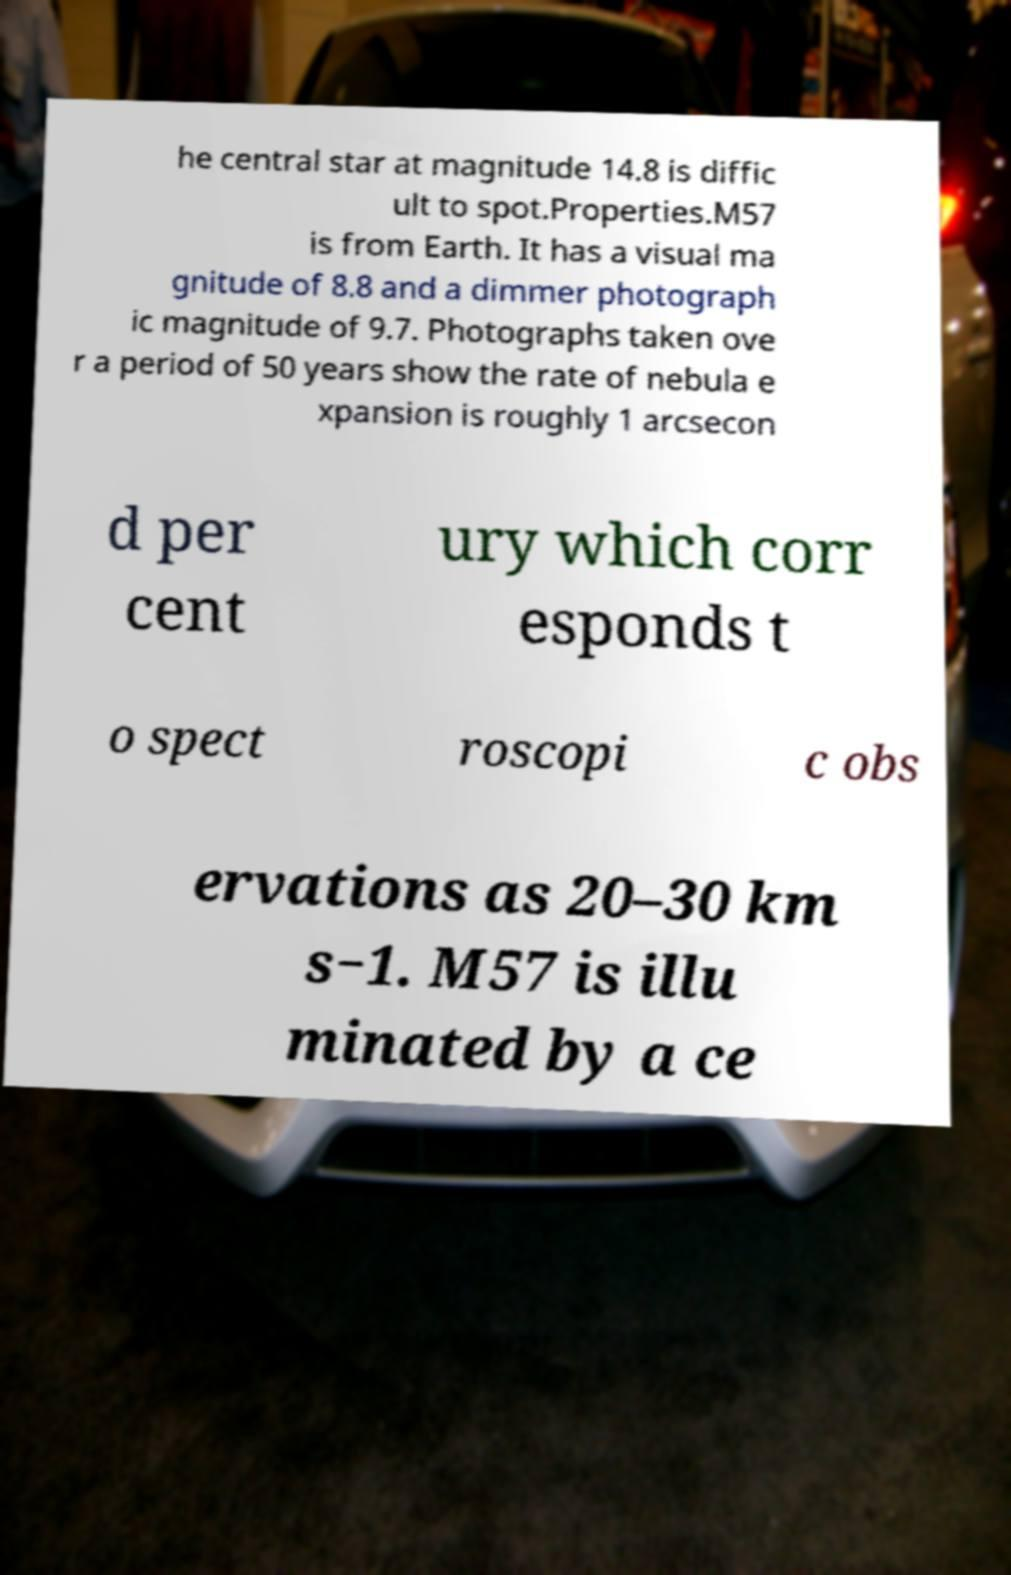Can you read and provide the text displayed in the image?This photo seems to have some interesting text. Can you extract and type it out for me? he central star at magnitude 14.8 is diffic ult to spot.Properties.M57 is from Earth. It has a visual ma gnitude of 8.8 and a dimmer photograph ic magnitude of 9.7. Photographs taken ove r a period of 50 years show the rate of nebula e xpansion is roughly 1 arcsecon d per cent ury which corr esponds t o spect roscopi c obs ervations as 20–30 km s−1. M57 is illu minated by a ce 